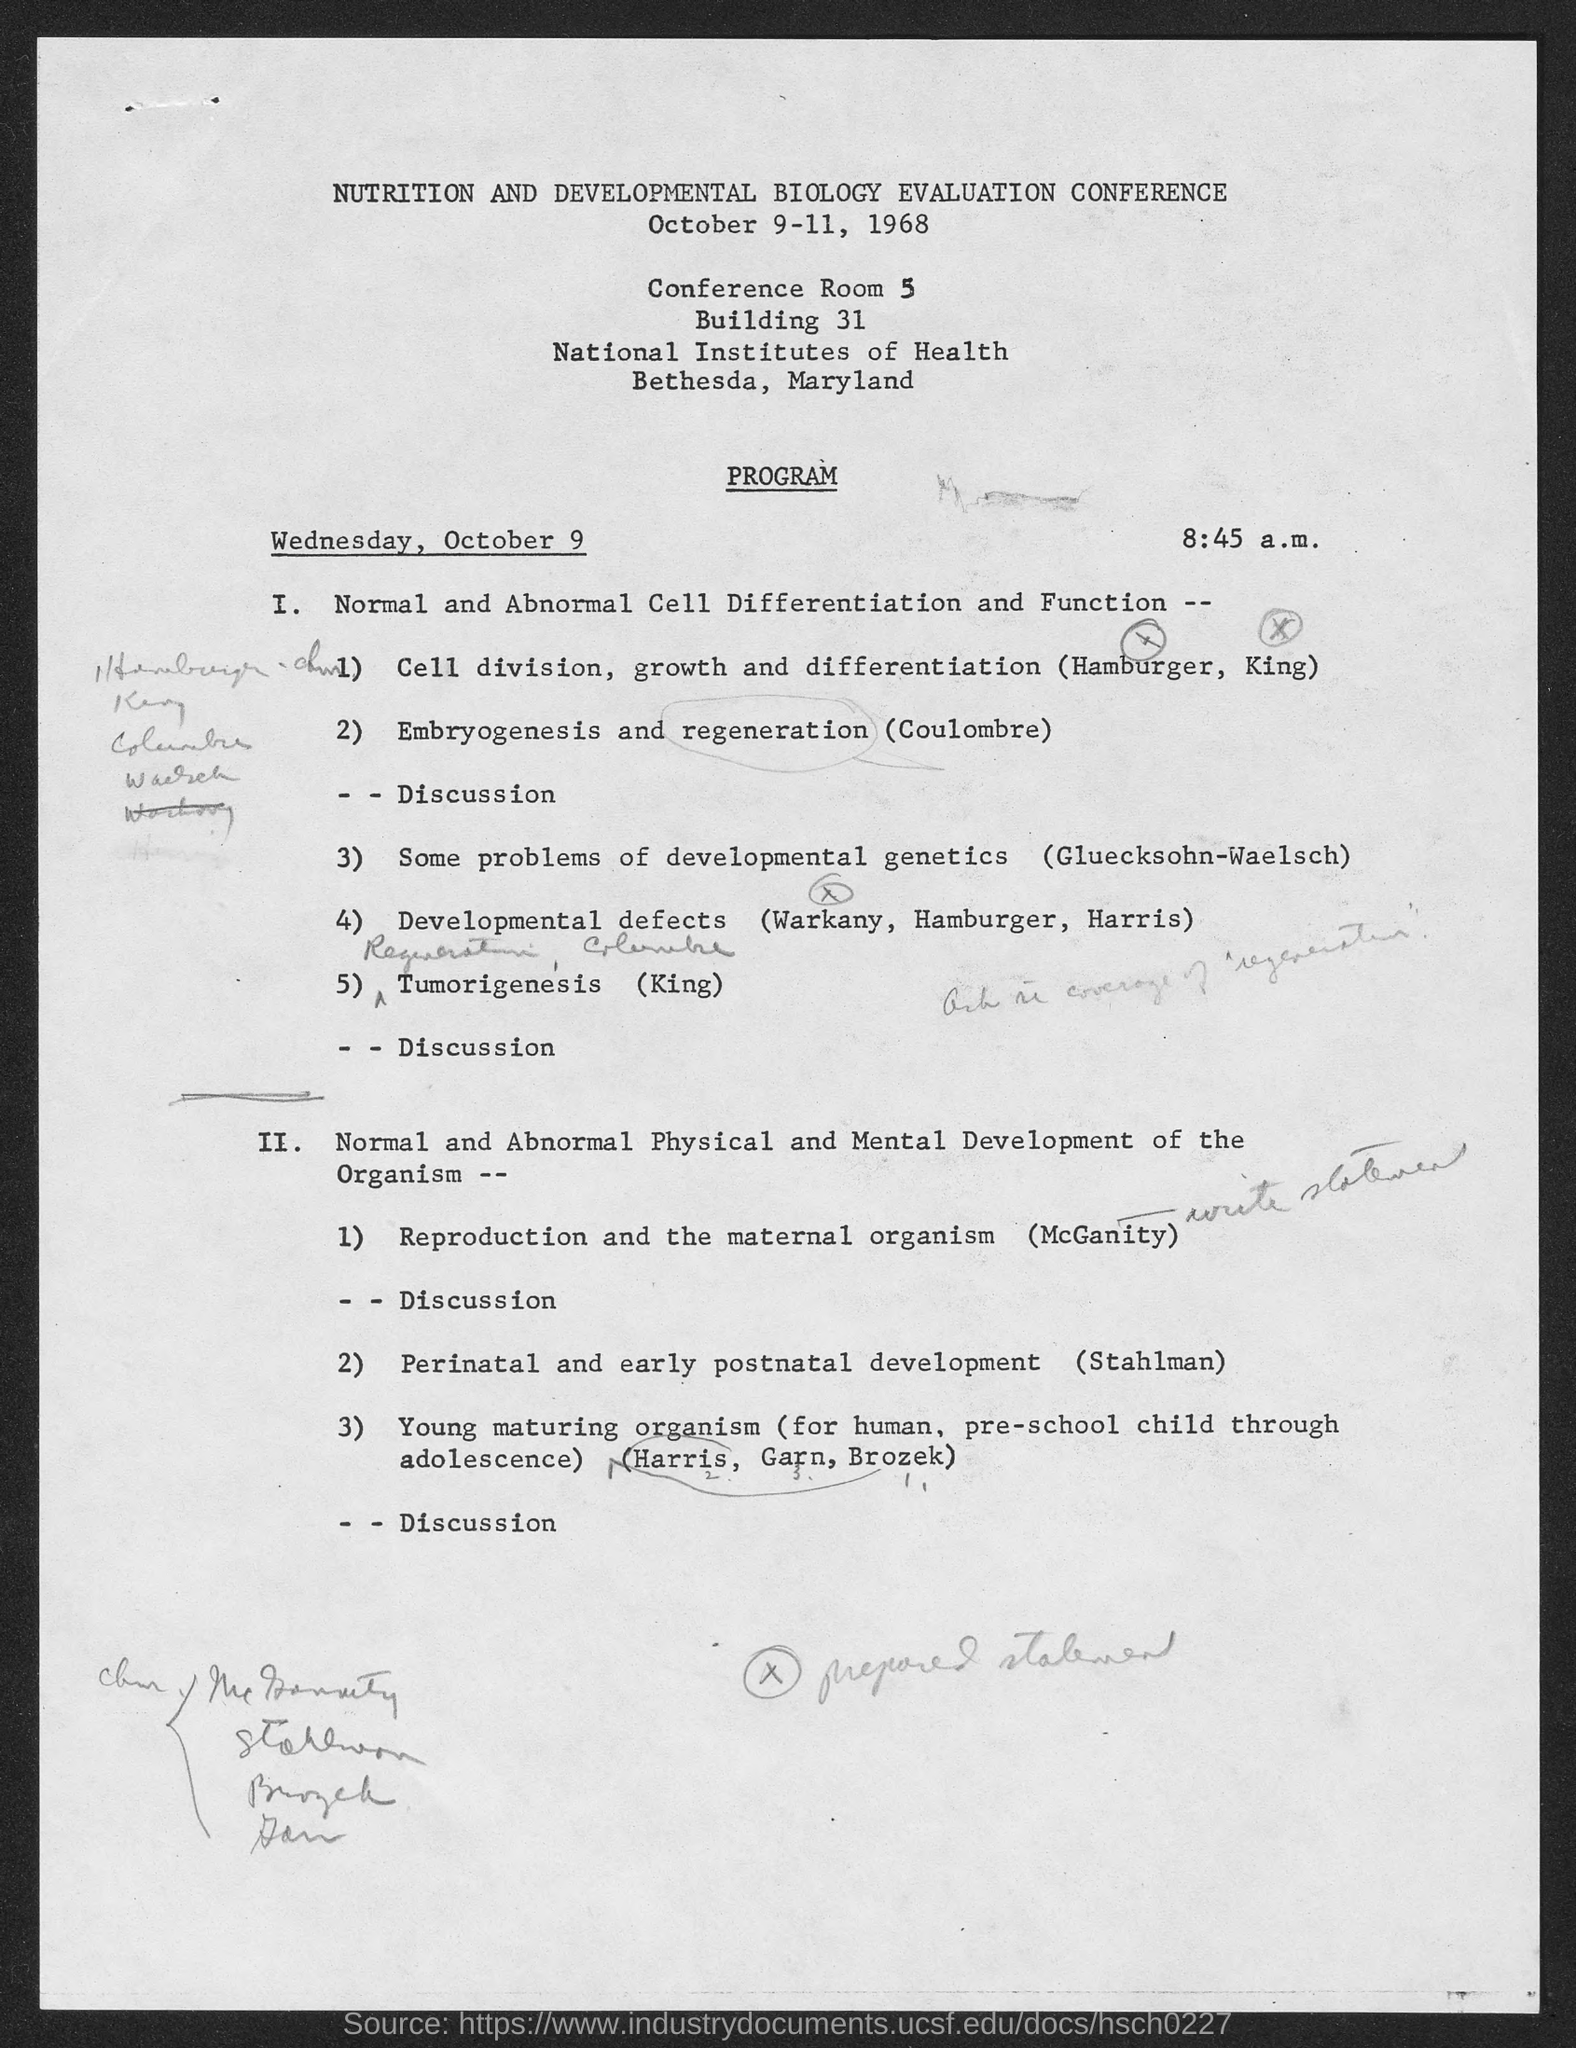Identify some key points in this picture. The development of a tumor is presented by King... The conference will take place on October 9-11, 1968. 